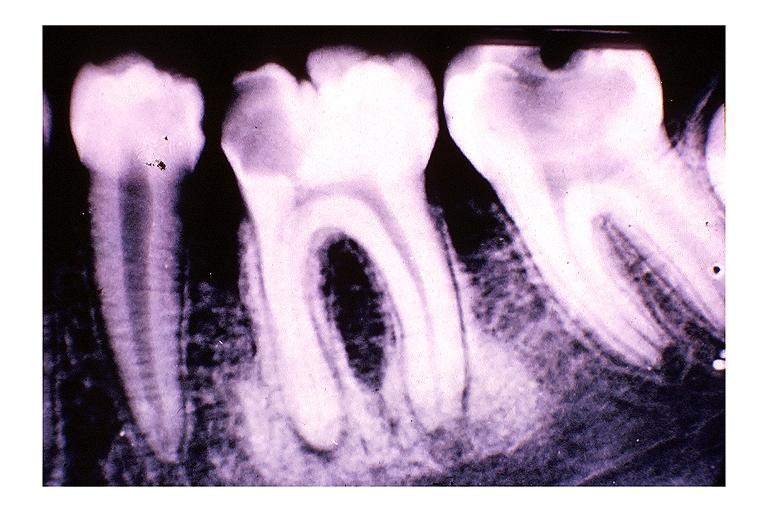does lymphoma show focal sclerosing osteomyelitis condensing osteitis?
Answer the question using a single word or phrase. No 